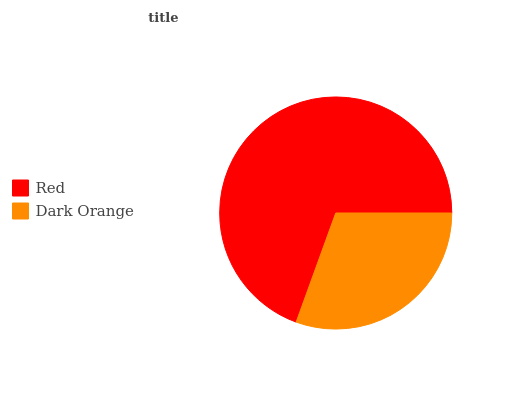Is Dark Orange the minimum?
Answer yes or no. Yes. Is Red the maximum?
Answer yes or no. Yes. Is Dark Orange the maximum?
Answer yes or no. No. Is Red greater than Dark Orange?
Answer yes or no. Yes. Is Dark Orange less than Red?
Answer yes or no. Yes. Is Dark Orange greater than Red?
Answer yes or no. No. Is Red less than Dark Orange?
Answer yes or no. No. Is Red the high median?
Answer yes or no. Yes. Is Dark Orange the low median?
Answer yes or no. Yes. Is Dark Orange the high median?
Answer yes or no. No. Is Red the low median?
Answer yes or no. No. 